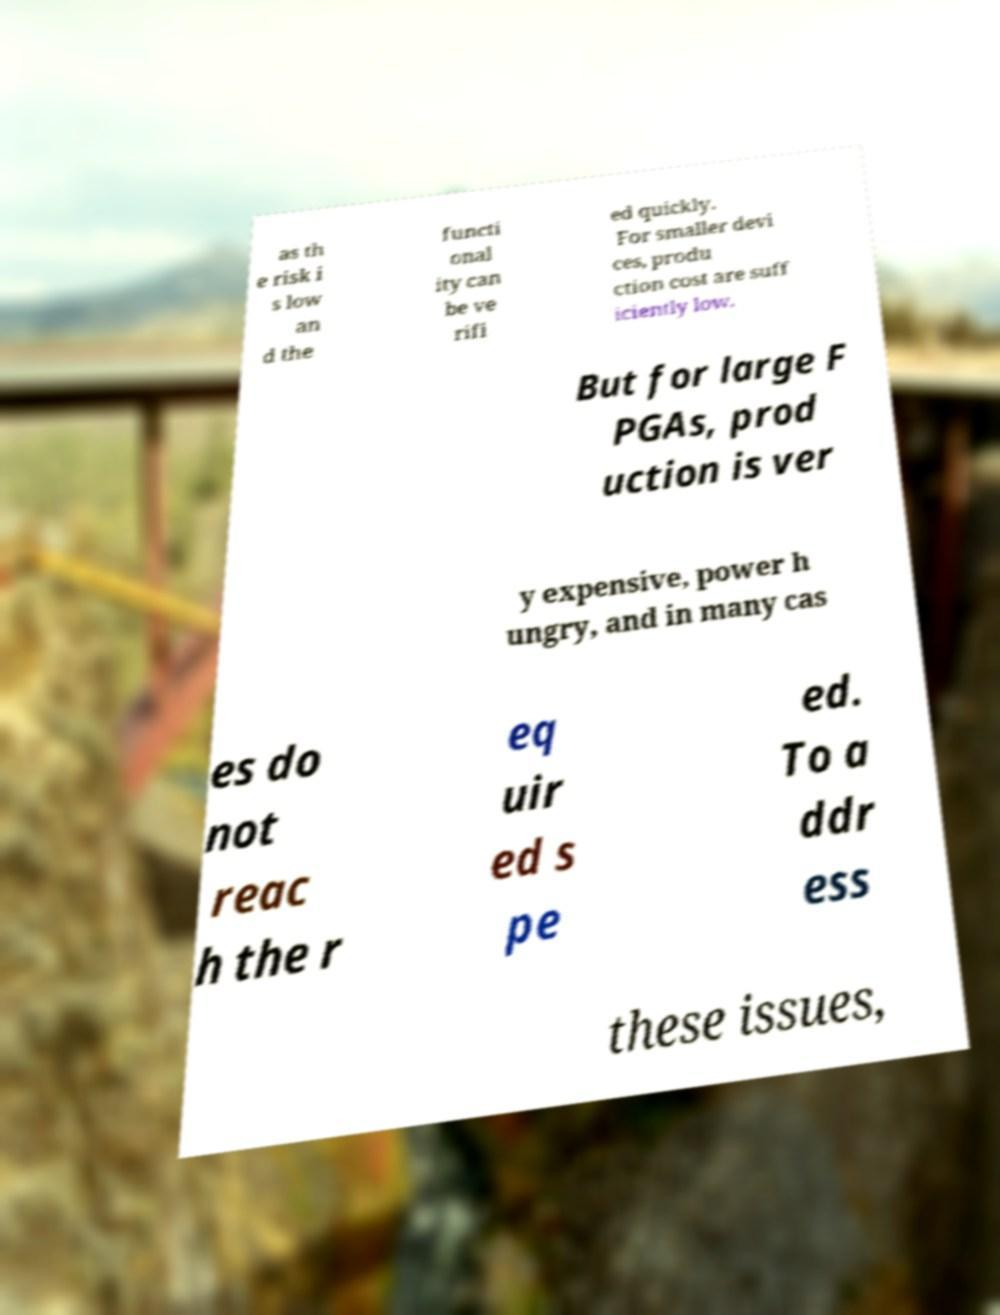Could you assist in decoding the text presented in this image and type it out clearly? as th e risk i s low an d the functi onal ity can be ve rifi ed quickly. For smaller devi ces, produ ction cost are suff iciently low. But for large F PGAs, prod uction is ver y expensive, power h ungry, and in many cas es do not reac h the r eq uir ed s pe ed. To a ddr ess these issues, 